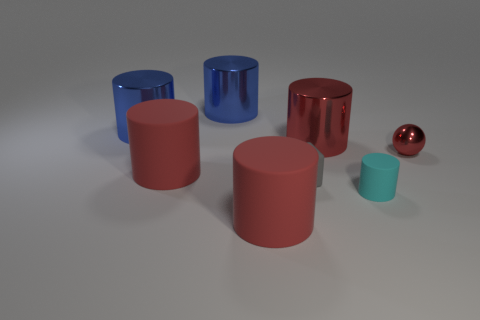Subtract all red cylinders. How many were subtracted if there are1red cylinders left? 2 Subtract all purple cubes. How many red cylinders are left? 3 Subtract all large red metallic cylinders. How many cylinders are left? 5 Subtract all cyan cylinders. How many cylinders are left? 5 Subtract 4 cylinders. How many cylinders are left? 2 Subtract all yellow cylinders. Subtract all red spheres. How many cylinders are left? 6 Add 1 gray objects. How many objects exist? 9 Subtract all cubes. How many objects are left? 7 Add 7 small metallic objects. How many small metallic objects are left? 8 Add 3 blue metallic objects. How many blue metallic objects exist? 5 